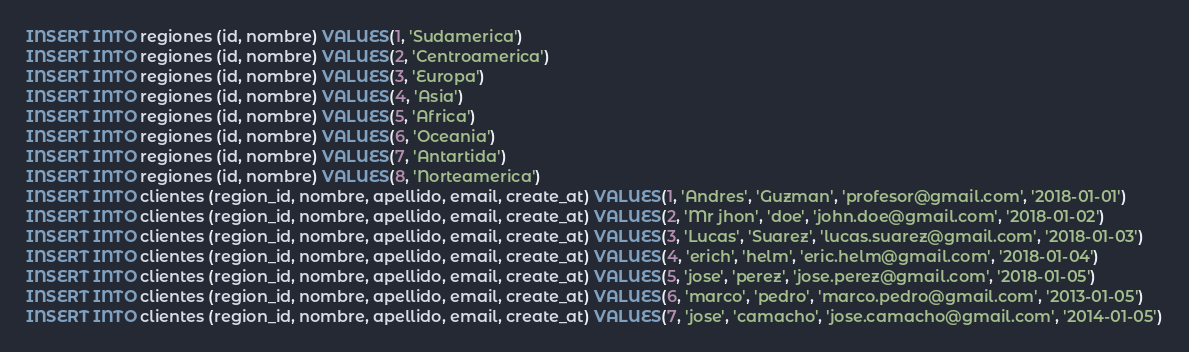<code> <loc_0><loc_0><loc_500><loc_500><_SQL_>INSERT INTO regiones (id, nombre) VALUES(1, 'Sudamerica')
INSERT INTO regiones (id, nombre) VALUES(2, 'Centroamerica')
INSERT INTO regiones (id, nombre) VALUES(3, 'Europa')
INSERT INTO regiones (id, nombre) VALUES(4, 'Asia')
INSERT INTO regiones (id, nombre) VALUES(5, 'Africa')
INSERT INTO regiones (id, nombre) VALUES(6, 'Oceania')
INSERT INTO regiones (id, nombre) VALUES(7, 'Antartida')
INSERT INTO regiones (id, nombre) VALUES(8, 'Norteamerica')
INSERT INTO clientes (region_id, nombre, apellido, email, create_at) VALUES(1, 'Andres', 'Guzman', 'profesor@gmail.com', '2018-01-01')
INSERT INTO clientes (region_id, nombre, apellido, email, create_at) VALUES(2, 'Mr jhon', 'doe', 'john.doe@gmail.com', '2018-01-02')
INSERT INTO clientes (region_id, nombre, apellido, email, create_at) VALUES(3, 'Lucas', 'Suarez', 'lucas.suarez@gmail.com', '2018-01-03')
INSERT INTO clientes (region_id, nombre, apellido, email, create_at) VALUES(4, 'erich', 'helm', 'eric.helm@gmail.com', '2018-01-04')
INSERT INTO clientes (region_id, nombre, apellido, email, create_at) VALUES(5, 'jose', 'perez', 'jose.perez@gmail.com', '2018-01-05')
INSERT INTO clientes (region_id, nombre, apellido, email, create_at) VALUES(6, 'marco', 'pedro', 'marco.pedro@gmail.com', '2013-01-05')
INSERT INTO clientes (region_id, nombre, apellido, email, create_at) VALUES(7, 'jose', 'camacho', 'jose.camacho@gmail.com', '2014-01-05')</code> 